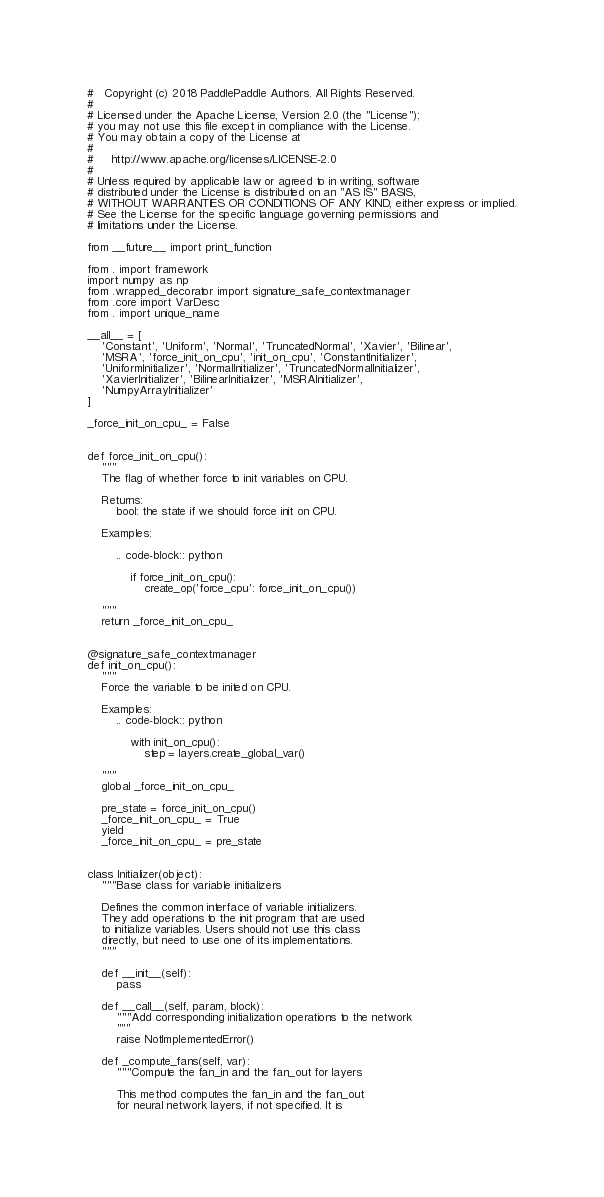Convert code to text. <code><loc_0><loc_0><loc_500><loc_500><_Python_>#   Copyright (c) 2018 PaddlePaddle Authors. All Rights Reserved.
#
# Licensed under the Apache License, Version 2.0 (the "License");
# you may not use this file except in compliance with the License.
# You may obtain a copy of the License at
#
#     http://www.apache.org/licenses/LICENSE-2.0
#
# Unless required by applicable law or agreed to in writing, software
# distributed under the License is distributed on an "AS IS" BASIS,
# WITHOUT WARRANTIES OR CONDITIONS OF ANY KIND, either express or implied.
# See the License for the specific language governing permissions and
# limitations under the License.

from __future__ import print_function

from . import framework
import numpy as np
from .wrapped_decorator import signature_safe_contextmanager
from .core import VarDesc
from . import unique_name

__all__ = [
    'Constant', 'Uniform', 'Normal', 'TruncatedNormal', 'Xavier', 'Bilinear',
    'MSRA', 'force_init_on_cpu', 'init_on_cpu', 'ConstantInitializer',
    'UniformInitializer', 'NormalInitializer', 'TruncatedNormalInitializer',
    'XavierInitializer', 'BilinearInitializer', 'MSRAInitializer',
    'NumpyArrayInitializer'
]

_force_init_on_cpu_ = False


def force_init_on_cpu():
    """
    The flag of whether force to init variables on CPU.

    Returns:
        bool: the state if we should force init on CPU.

    Examples:

        .. code-block:: python

            if force_init_on_cpu():
                create_op('force_cpu': force_init_on_cpu())

    """
    return _force_init_on_cpu_


@signature_safe_contextmanager
def init_on_cpu():
    """
    Force the variable to be inited on CPU.

    Examples:
        .. code-block:: python

            with init_on_cpu():
                step = layers.create_global_var()

    """
    global _force_init_on_cpu_

    pre_state = force_init_on_cpu()
    _force_init_on_cpu_ = True
    yield
    _force_init_on_cpu_ = pre_state


class Initializer(object):
    """Base class for variable initializers

    Defines the common interface of variable initializers.
    They add operations to the init program that are used
    to initialize variables. Users should not use this class
    directly, but need to use one of its implementations.
    """

    def __init__(self):
        pass

    def __call__(self, param, block):
        """Add corresponding initialization operations to the network
        """
        raise NotImplementedError()

    def _compute_fans(self, var):
        """Compute the fan_in and the fan_out for layers

        This method computes the fan_in and the fan_out
        for neural network layers, if not specified. It is</code> 